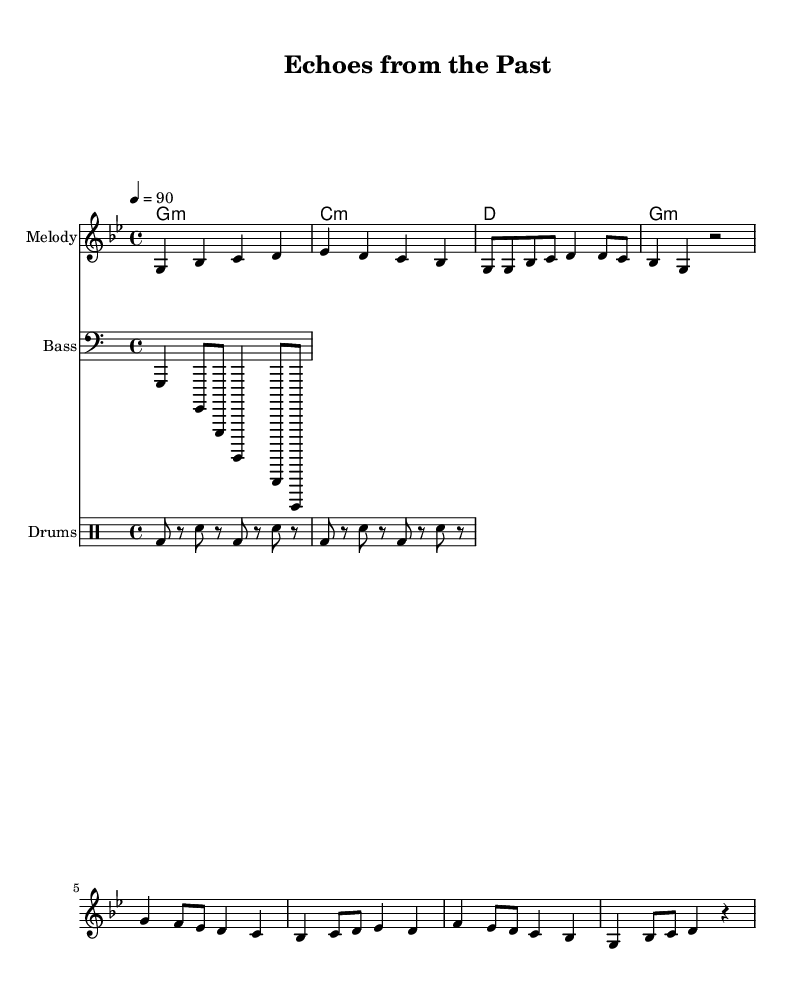What is the key signature of this music? The key signature indicates that the music is in G minor, which has two flats, B-flat and E-flat. This can be identified from the key signature notation at the beginning of the score.
Answer: G minor What is the time signature of this music? The time signature is found at the beginning of the score and shows that it is in 4/4 time, meaning there are four beats in each measure and the quarter note gets the beat.
Answer: 4/4 What is the tempo marking of this piece? The tempo marking indicates the speed at which the music should be played and is given as 4 = 90, which means there are 90 beats per minute. This notation can be found near the top of the score.
Answer: 90 How many measures are in the verse section of the score? To count the measures in the verse section, we look at the corresponding music bars indicated in the melody part. The verse section includes four measures, which can be counted visually from the notation.
Answer: 4 What instruments are used in this piece? By examining the score, we can see that the music is arranged for three types: Melody (likely a lead instrument), Bass (indicated with a bass clef), and Drums (noted under a drum staff).
Answer: Melody, Bass, Drums What is the rhythm pattern used in the chorus section? To analyze the rhythm pattern in the chorus, we can identify the sequence of notes and rests: the sequence includes quarter notes and eighth notes arranged in a specific manner, creating a rhythmic flow unique to this section.
Answer: Quarter and eighth notes How does the bass pattern complement the melody in this piece? The bass pattern generally follows the root notes of the harmonic structure shown in the chord symbols. This relationship creates a foundation that supports the melody while providing harmonic depth. The bass notes correspond to the same chords indicated for the harmony, which enhances the overall sound.
Answer: Root notes 